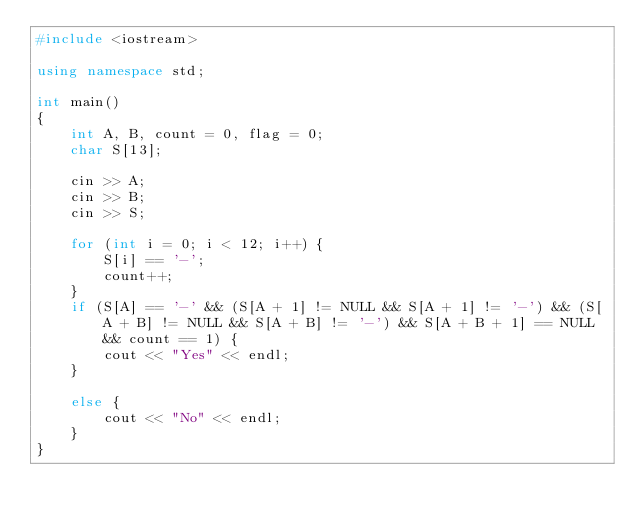<code> <loc_0><loc_0><loc_500><loc_500><_C++_>#include <iostream>

using namespace std;

int main()
{
	int A, B, count = 0, flag = 0;
	char S[13];

	cin >> A;
	cin >> B;
	cin >> S;

	for (int i = 0; i < 12; i++) {
		S[i] == '-';
		count++;
	}
	if (S[A] == '-' && (S[A + 1] != NULL && S[A + 1] != '-') && (S[A + B] != NULL && S[A + B] != '-') && S[A + B + 1] == NULL && count == 1) {
		cout << "Yes" << endl;
	}

	else {
		cout << "No" << endl;
	}
}</code> 